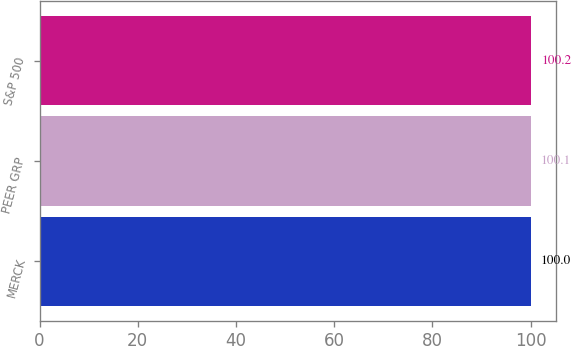<chart> <loc_0><loc_0><loc_500><loc_500><bar_chart><fcel>MERCK<fcel>PEER GRP<fcel>S&P 500<nl><fcel>100<fcel>100.1<fcel>100.2<nl></chart> 